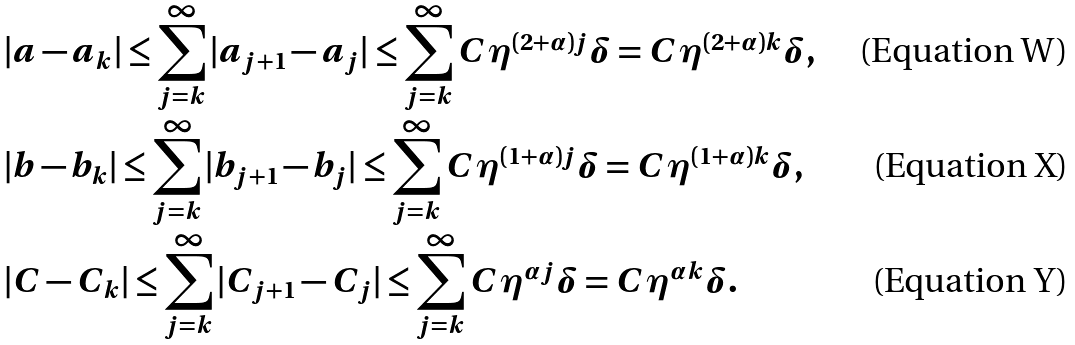<formula> <loc_0><loc_0><loc_500><loc_500>& | a - a _ { k } | \leq \sum _ { j = k } ^ { \infty } | a _ { j + 1 } - a _ { j } | \leq \sum _ { j = k } ^ { \infty } C \eta ^ { ( 2 + \alpha ) j } \delta = C \eta ^ { ( 2 + \alpha ) k } \delta , \\ & | b - b _ { k } | \leq \sum _ { j = k } ^ { \infty } | b _ { j + 1 } - b _ { j } | \leq \sum _ { j = k } ^ { \infty } C \eta ^ { ( 1 + \alpha ) j } \delta = C \eta ^ { ( 1 + \alpha ) k } \delta , \\ & | C - C _ { k } | \leq \sum _ { j = k } ^ { \infty } | C _ { j + 1 } - C _ { j } | \leq \sum _ { j = k } ^ { \infty } C \eta ^ { \alpha j } \delta = C \eta ^ { \alpha k } \delta .</formula> 